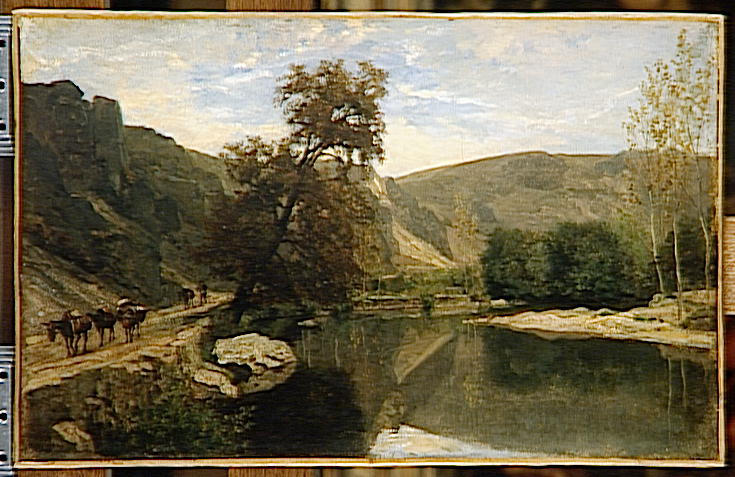What techniques did the artist use to achieve the reflection of the sky in the water? The artist has adeptly used a combination of lighter brush strokes and color blending to create the reflection of the sky in the water. By mirroring the pale blue of the sky and the wispy white of the clouds, the water effectively reflects the sky's color palette, enhancing the painting's overall sense of depth and serenity. The subtle ripples in the water are indicated by gentle horizontal strokes, which suggest movement while maintaining the reflective quality. 